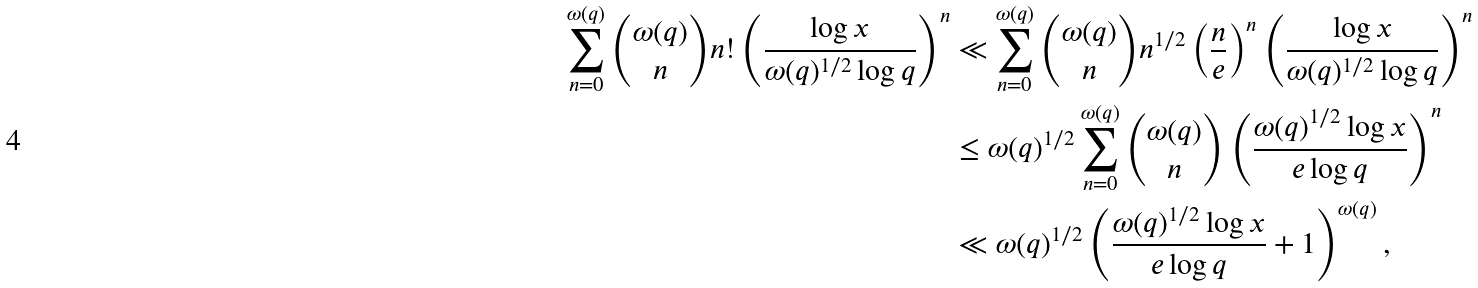Convert formula to latex. <formula><loc_0><loc_0><loc_500><loc_500>\sum _ { n = 0 } ^ { \omega ( q ) } \binom { \omega ( q ) } { n } n ! \left ( \frac { \log { x } } { \omega ( q ) ^ { 1 / 2 } \log { q } } \right ) ^ { n } & \ll \sum _ { n = 0 } ^ { \omega ( q ) } \binom { \omega ( q ) } { n } n ^ { 1 / 2 } \left ( \frac { n } { e } \right ) ^ { n } \left ( \frac { \log { x } } { \omega ( q ) ^ { 1 / 2 } \log { q } } \right ) ^ { n } \\ & \leq \omega ( q ) ^ { 1 / 2 } \sum _ { n = 0 } ^ { \omega ( q ) } \binom { \omega ( q ) } { n } \left ( \frac { \omega { ( q ) } ^ { 1 / 2 } \log { x } } { e \log { q } } \right ) ^ { n } \\ & \ll \omega ( q ) ^ { 1 / 2 } \left ( \frac { \omega ( q ) ^ { 1 / 2 } \log { x } } { e \log { q } } + 1 \right ) ^ { \omega { ( q ) } } ,</formula> 